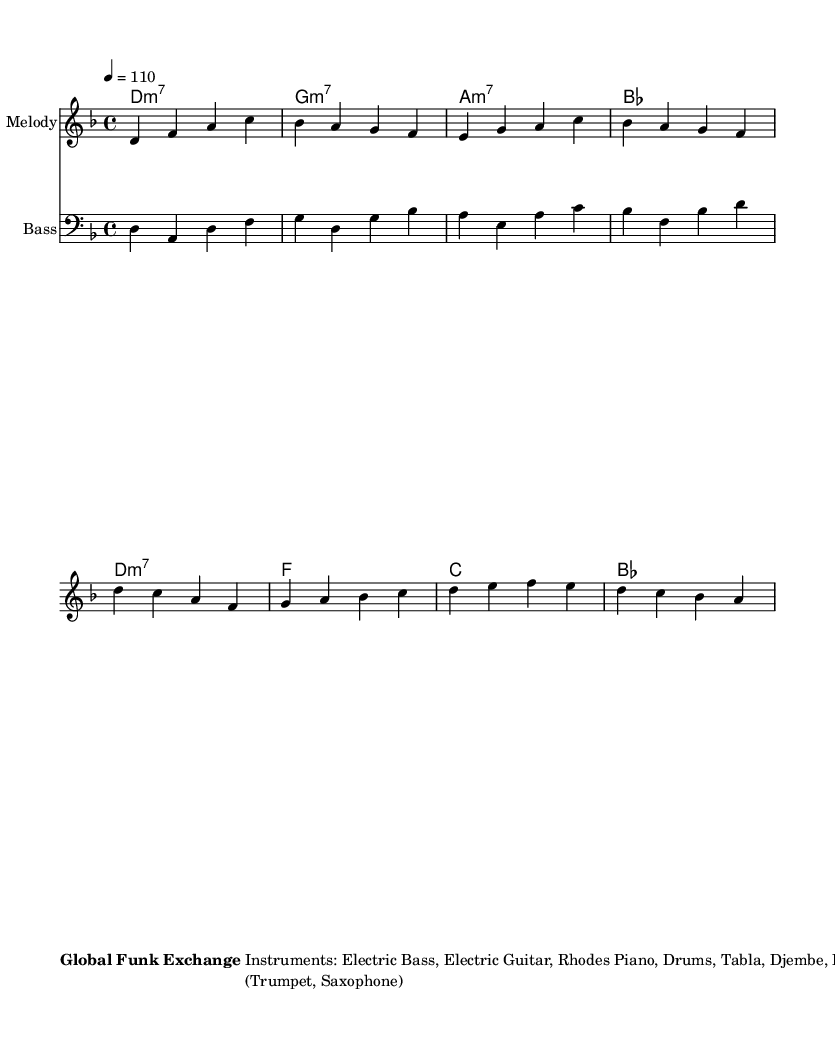What is the key signature of this music? The key signature is D minor, which is indicated by one flat (B flat). The presence of the flat in the key signature shows that the piece is in D minor.
Answer: D minor What is the time signature of the piece? The time signature is indicated at the beginning of the score and is written as 4/4, which means there are four beats per measure.
Answer: 4/4 What is the tempo of the music? The tempo is indicated at the beginning of the music with 4 = 110, which means there are 110 quarter-note beats per minute.
Answer: 110 How many sections does this piece have? The structure of the piece is clearly noted and includes Intro, Verse, Chorus, Verse, Chorus, Bridge, Chorus, and Outro, making a total of 7 sections.
Answer: 7 Which instruments are included in this arrangement? The instruments are listed in the markup section and include Electric Bass, Electric Guitar, Rhodes Piano, Drums, Tabla, Djembe, and a Brass Section.
Answer: Electric Bass, Electric Guitar, Rhodes Piano, Drums, Tabla, Djembe, Brass Section What kind of special instructions are given for the bridge section? The special instructions state to incorporate tabla and djembe solos during the bridge, focusing on the use of these instruments for solos specifically in this part of the music.
Answer: Incorporate tabla and djembe solos 